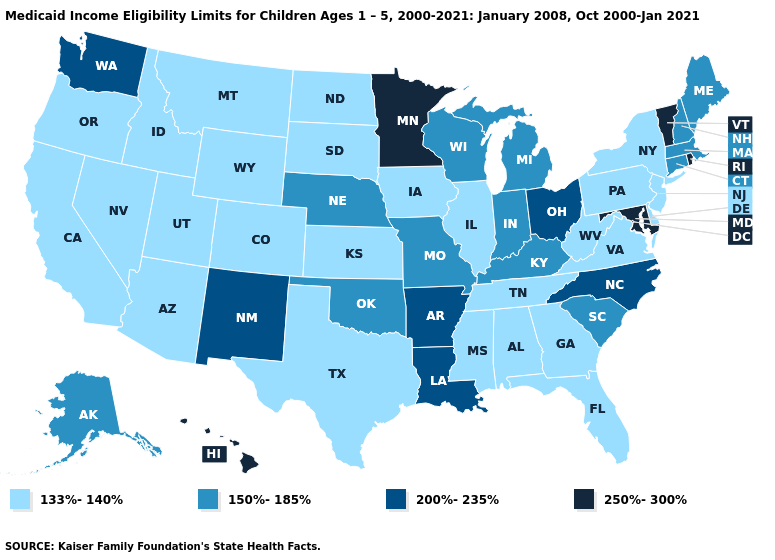What is the highest value in the Northeast ?
Be succinct. 250%-300%. Name the states that have a value in the range 250%-300%?
Quick response, please. Hawaii, Maryland, Minnesota, Rhode Island, Vermont. Among the states that border Tennessee , does North Carolina have the highest value?
Answer briefly. Yes. What is the value of Florida?
Short answer required. 133%-140%. Which states hav the highest value in the South?
Keep it brief. Maryland. Name the states that have a value in the range 200%-235%?
Short answer required. Arkansas, Louisiana, New Mexico, North Carolina, Ohio, Washington. What is the value of Arizona?
Be succinct. 133%-140%. Which states have the lowest value in the Northeast?
Give a very brief answer. New Jersey, New York, Pennsylvania. Does Washington have the lowest value in the USA?
Quick response, please. No. Does the map have missing data?
Write a very short answer. No. What is the lowest value in the West?
Be succinct. 133%-140%. Which states have the lowest value in the Northeast?
Quick response, please. New Jersey, New York, Pennsylvania. What is the lowest value in states that border New York?
Concise answer only. 133%-140%. Does Illinois have the highest value in the USA?
Short answer required. No. What is the value of Georgia?
Be succinct. 133%-140%. 